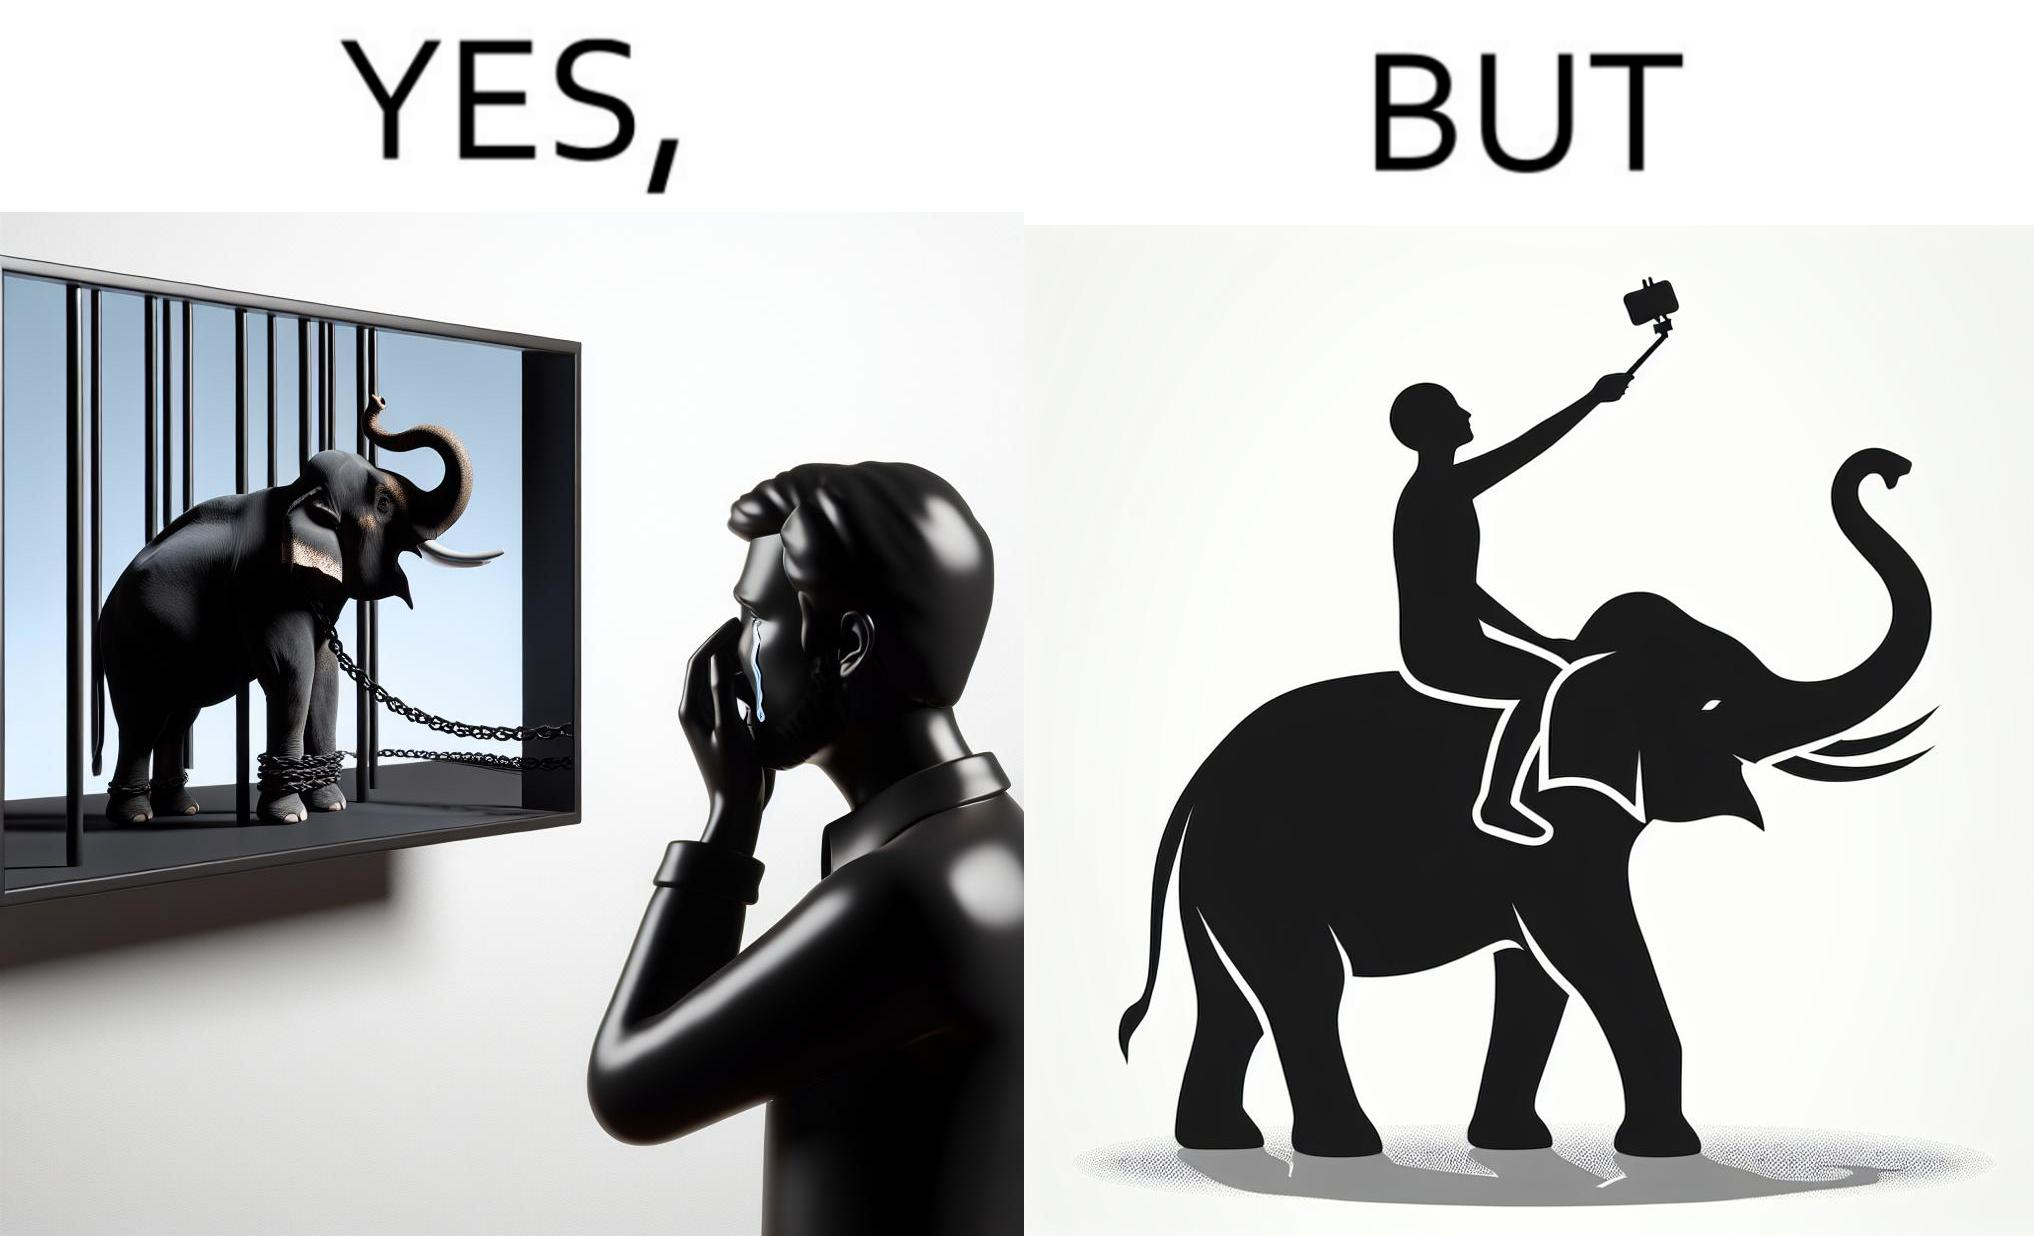What does this image depict? The image is ironic, because the people who get sentimental over imprisoned animal while watching TV shows often feel okay when using animals for labor 